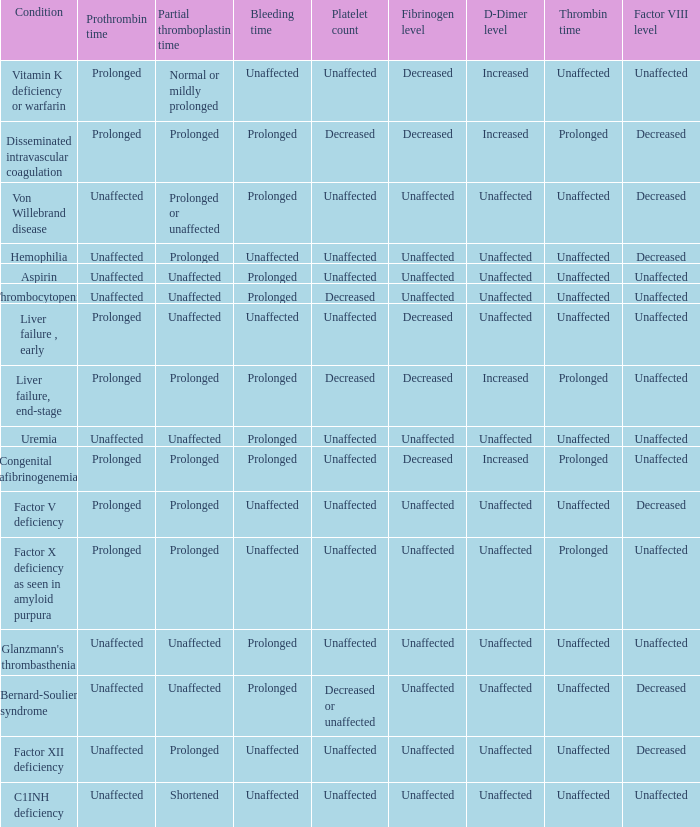I'm looking to parse the entire table for insights. Could you assist me with that? {'header': ['Condition', 'Prothrombin time', 'Partial thromboplastin time', 'Bleeding time', 'Platelet count', 'Fibrinogen level', 'D-Dimer level', 'Thrombin time', 'Factor VIII level'], 'rows': [['Vitamin K deficiency or warfarin', 'Prolonged', 'Normal or mildly prolonged', 'Unaffected', 'Unaffected', 'Decreased', 'Increased', 'Unaffected', 'Unaffected'], ['Disseminated intravascular coagulation', 'Prolonged', 'Prolonged', 'Prolonged', 'Decreased', 'Decreased', 'Increased', 'Prolonged', 'Decreased'], ['Von Willebrand disease', 'Unaffected', 'Prolonged or unaffected', 'Prolonged', 'Unaffected', 'Unaffected', 'Unaffected', 'Unaffected', 'Decreased'], ['Hemophilia', 'Unaffected', 'Prolonged', 'Unaffected', 'Unaffected', 'Unaffected', 'Unaffected', 'Unaffected', 'Decreased'], ['Aspirin', 'Unaffected', 'Unaffected', 'Prolonged', 'Unaffected', 'Unaffected', 'Unaffected', 'Unaffected', 'Unaffected'], ['Thrombocytopenia', 'Unaffected', 'Unaffected', 'Prolonged', 'Decreased', 'Unaffected', 'Unaffected', 'Unaffected', 'Unaffected'], ['Liver failure , early', 'Prolonged', 'Unaffected', 'Unaffected', 'Unaffected', 'Decreased', 'Unaffected', 'Unaffected', 'Unaffected'], ['Liver failure, end-stage', 'Prolonged', 'Prolonged', 'Prolonged', 'Decreased', 'Decreased', 'Increased', 'Prolonged', 'Unaffected'], ['Uremia', 'Unaffected', 'Unaffected', 'Prolonged', 'Unaffected', 'Unaffected', 'Unaffected', 'Unaffected', 'Unaffected'], ['Congenital afibrinogenemia', 'Prolonged', 'Prolonged', 'Prolonged', 'Unaffected', 'Decreased', 'Increased', 'Prolonged', 'Unaffected'], ['Factor V deficiency', 'Prolonged', 'Prolonged', 'Unaffected', 'Unaffected', 'Unaffected', 'Unaffected', 'Unaffected', 'Decreased'], ['Factor X deficiency as seen in amyloid purpura', 'Prolonged', 'Prolonged', 'Unaffected', 'Unaffected', 'Unaffected', 'Unaffected', 'Prolonged', 'Unaffected'], ["Glanzmann's thrombasthenia", 'Unaffected', 'Unaffected', 'Prolonged', 'Unaffected', 'Unaffected', 'Unaffected', 'Unaffected', 'Unaffected'], ['Bernard-Soulier syndrome', 'Unaffected', 'Unaffected', 'Prolonged', 'Decreased or unaffected', 'Unaffected', 'Unaffected', 'Unaffected', 'Decreased'], ['Factor XII deficiency', 'Unaffected', 'Prolonged', 'Unaffected', 'Unaffected', 'Unaffected', 'Unaffected', 'Unaffected', 'Decreased'], ['C1INH deficiency', 'Unaffected', 'Shortened', 'Unaffected', 'Unaffected', 'Unaffected', 'Unaffected', 'Unaffected', 'Unaffected']]} Which partial thromboplastin time has a condition of liver failure , early? Unaffected. 